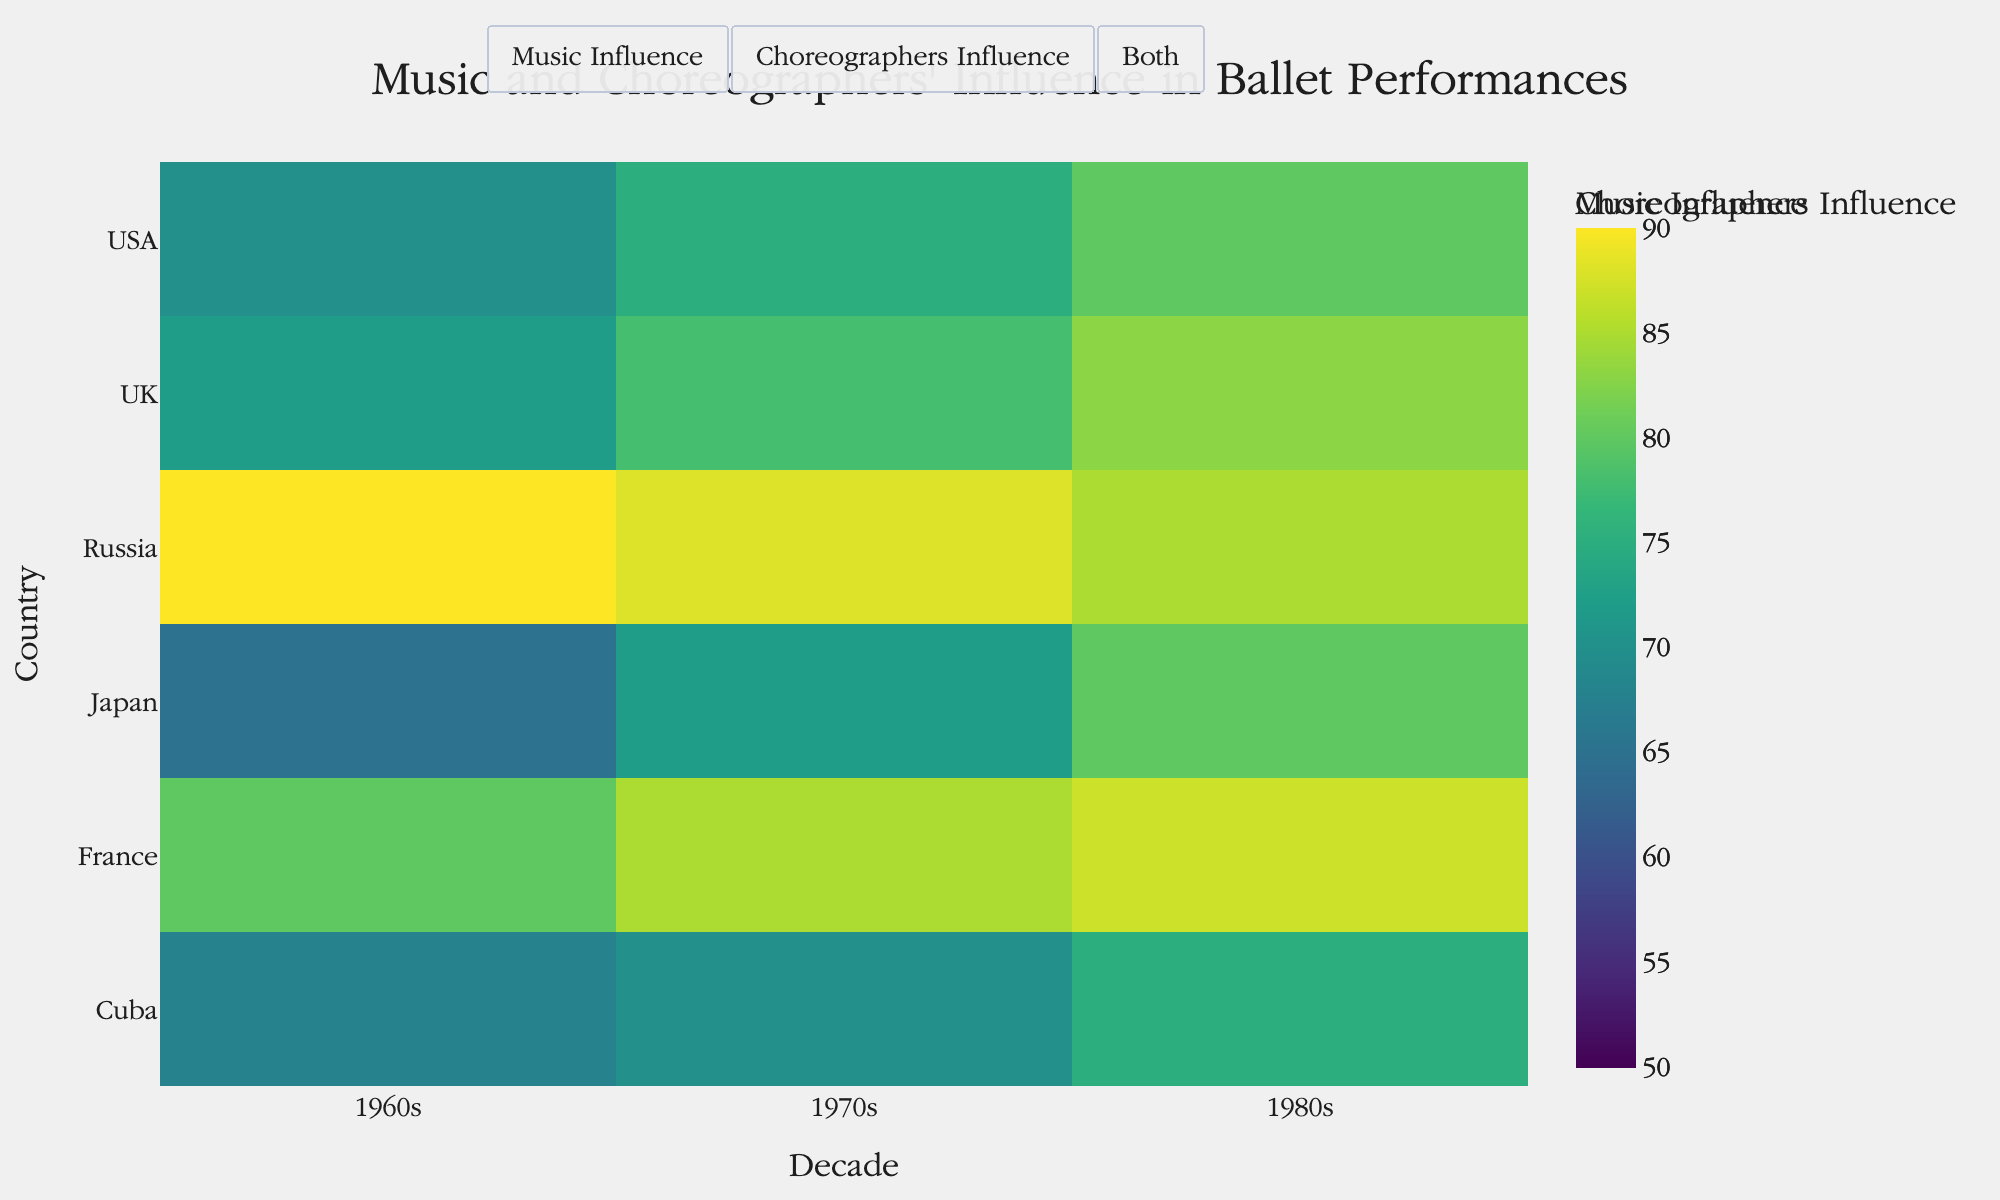What's the title of the figure? The title is usually prominently displayed at the top of the figure. You can read it directly from there.
Answer: Music and Choreographers' Influence in Ballet Performances Which country has the highest music influence in the 1980s? By examining the heatmap, find the row corresponding to the 1980s column and identify the country with the highest value.
Answer: Russia How does the choreographers' influence in Cuba change from the 1960s to the 1980s? Compare the choreographers' influence for Cuba across the decades by looking at the values in the respective columns for the 1960s, 1970s, and 1980s.
Answer: It increased from 68 to 75 Which country experienced the greatest increase in music influence from the 1960s to the 1980s? Calculate the difference in values between the 1960s and the 1980s for each country, and determine which country had the highest increase.
Answer: Japan Are there any countries where the choreographers' influence is higher than music influence in all decades? Investigate each row to see if, for all decades, the choreographers' influence consistently has higher values than music influence.
Answer: No What's the average choreographers' influence in the UK during the 1970s and 1980s? Sum the values for the 1970s and 1980s in the UK for choreographers' influence and divide by 2 to get the average.
Answer: 80.5 Which country had the lowest music influence in the 1960s, and what was the value? Identify the country with the lowest value in the music influence column for the 1960s.
Answer: Japan, 50 How does the music influence in the USA trend over the decades from the 1960s to the 1980s? Compare the music influence values for the USA across the 1960s, 1970s, and 1980s.
Answer: It increased Between France and the UK, which country had a higher average music influence in the 1980s? Calculate the average music influence for both France and the UK in the 1980s, then compare the two.
Answer: France 